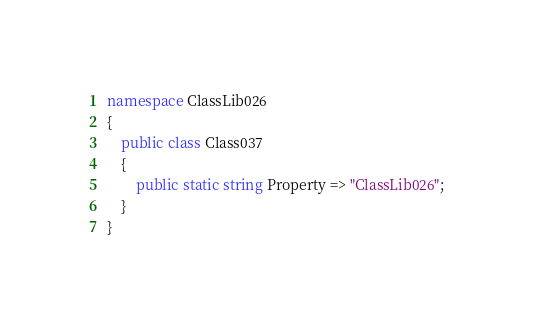<code> <loc_0><loc_0><loc_500><loc_500><_C#_>namespace ClassLib026
{
    public class Class037
    {
        public static string Property => "ClassLib026";
    }
}
</code> 